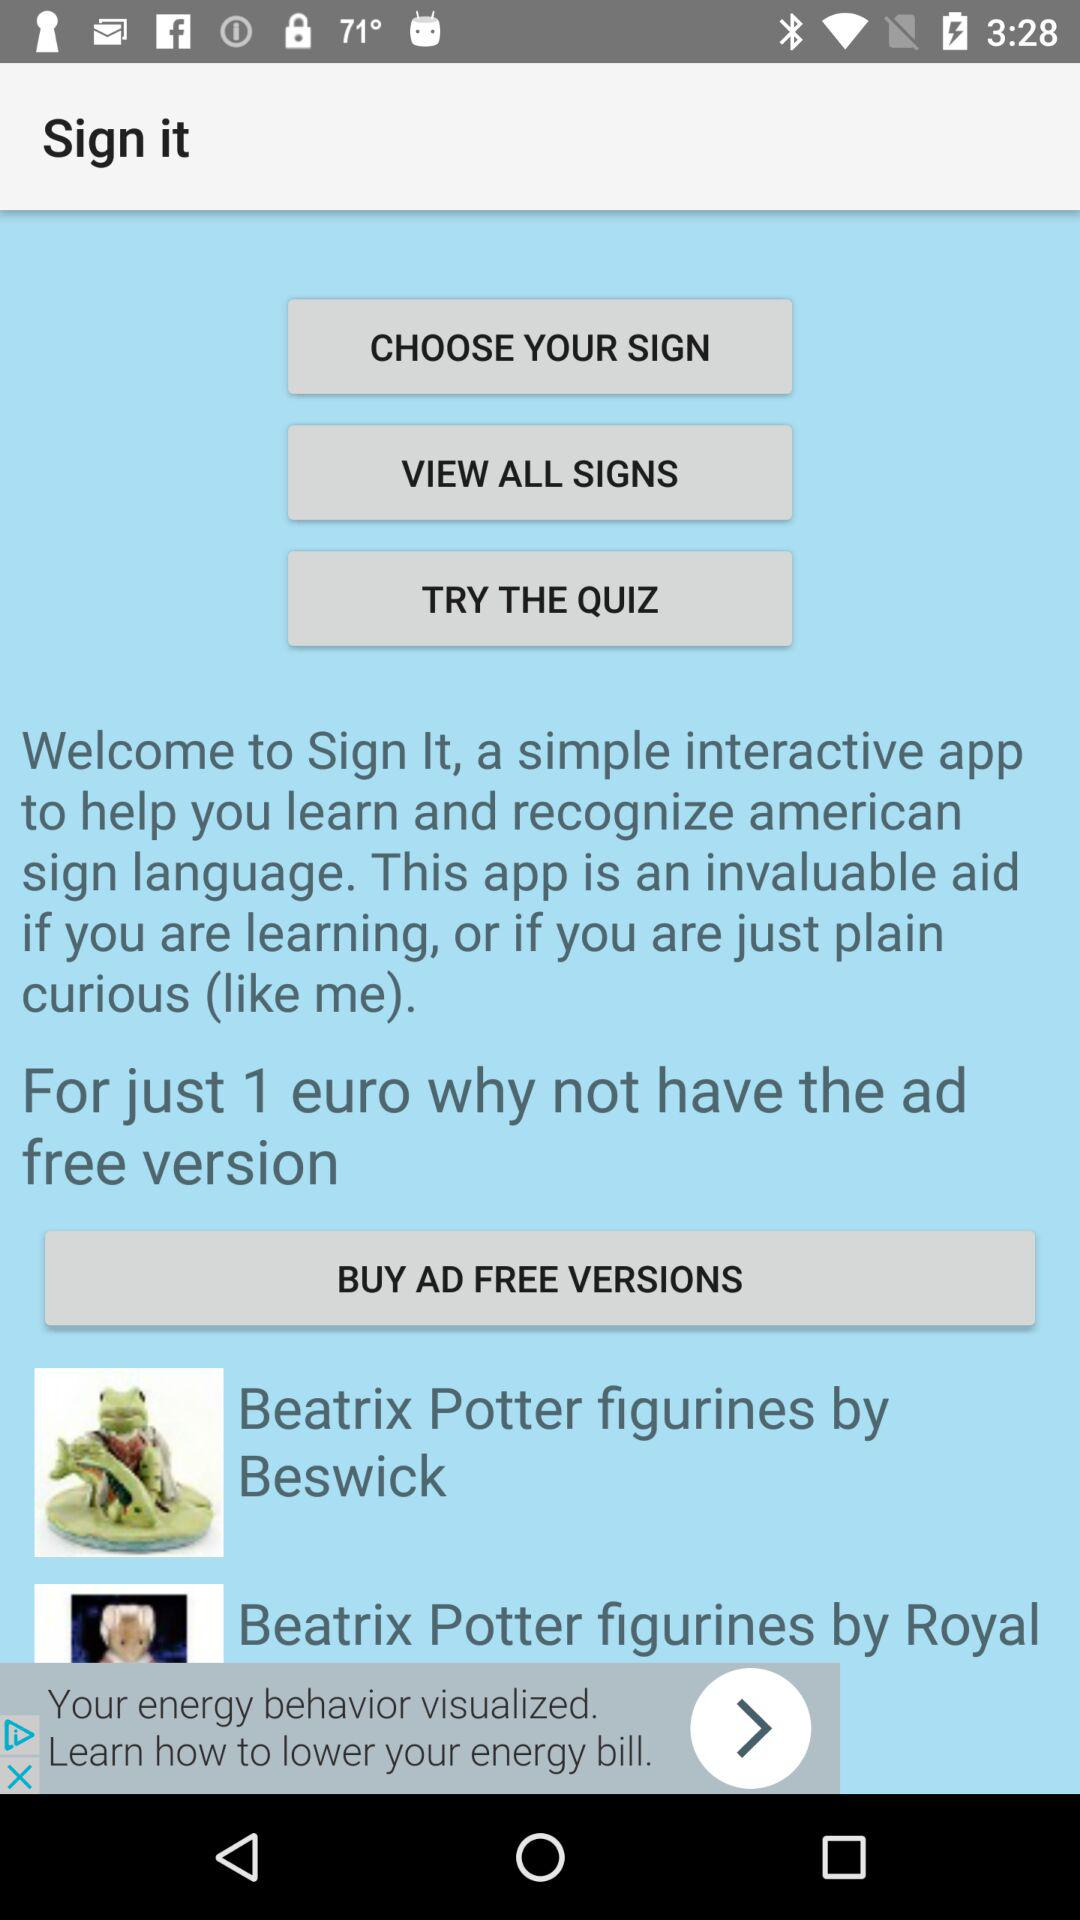How much does the ad-free version cost?
When the provided information is insufficient, respond with <no answer>. <no answer> 